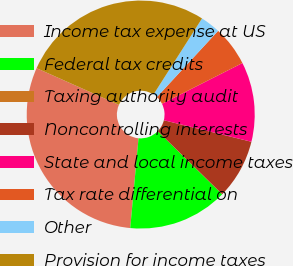Convert chart to OTSL. <chart><loc_0><loc_0><loc_500><loc_500><pie_chart><fcel>Income tax expense at US<fcel>Federal tax credits<fcel>Taxing authority audit<fcel>Noncontrolling interests<fcel>State and local income taxes<fcel>Tax rate differential on<fcel>Other<fcel>Provision for income taxes<nl><fcel>30.2%<fcel>14.13%<fcel>0.02%<fcel>8.48%<fcel>11.3%<fcel>5.66%<fcel>2.84%<fcel>27.37%<nl></chart> 